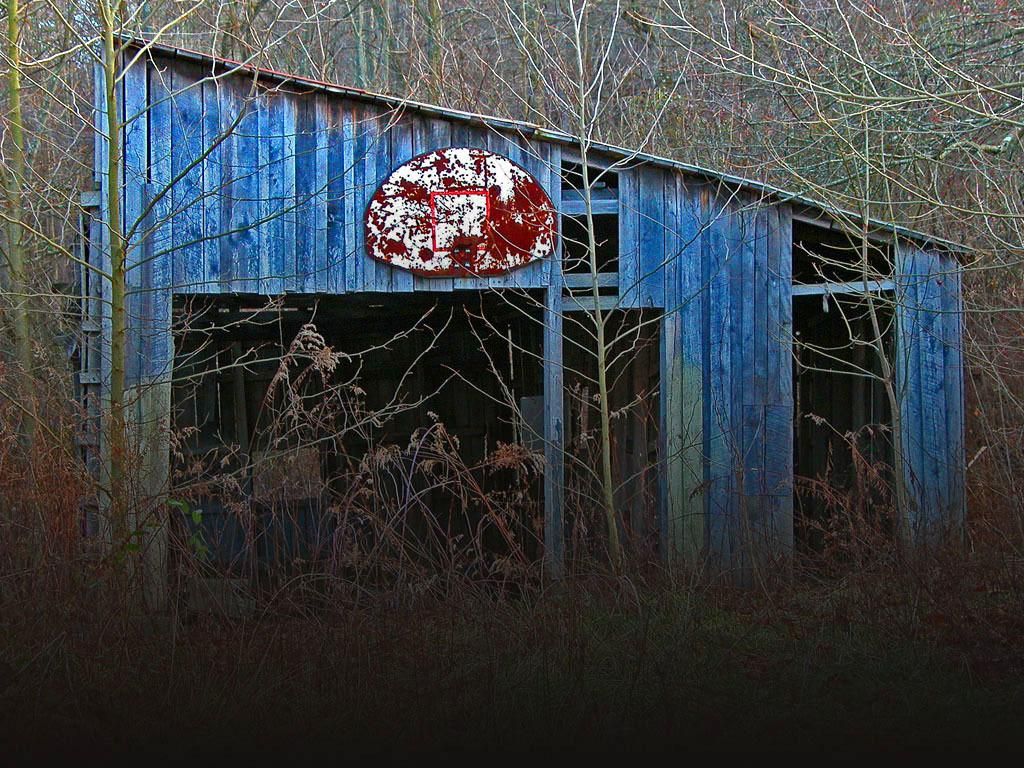Where was the image taken? The image was clicked outside the city. What is the main subject in the center of the image? There is a blue color cabin in the center of the image. What can be seen in the background of the image? There are trees and plants in the background of the image. What type of sweater is the person wearing in the image? There is no person visible in the image, and therefore no sweater can be observed. How many houses are present in the image? The image only features a blue color cabin, so there is only one house present. 